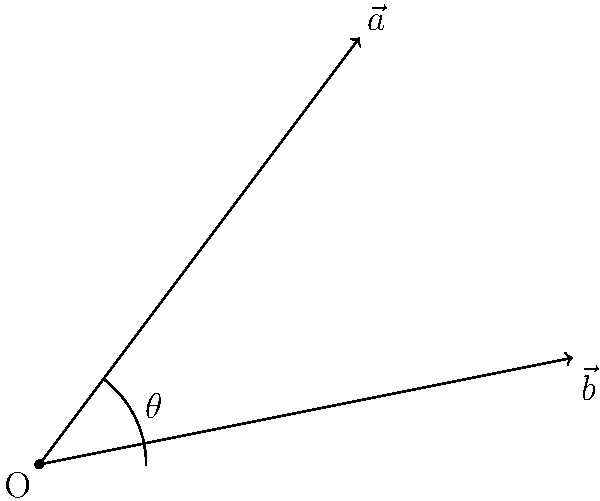In a hidden state park in the Sierra Nevada mountains, two hiking trails are represented by vectors $\vec{a} = (3, 4)$ and $\vec{b} = (5, 1)$. What is the angle $\theta$ between these two trails, rounded to the nearest degree? To find the angle between two vectors, we can use the dot product formula:

$$\cos \theta = \frac{\vec{a} \cdot \vec{b}}{|\vec{a}||\vec{b}|}$$

Step 1: Calculate the dot product $\vec{a} \cdot \vec{b}$
$$\vec{a} \cdot \vec{b} = (3)(5) + (4)(1) = 15 + 4 = 19$$

Step 2: Calculate the magnitudes of $\vec{a}$ and $\vec{b}$
$$|\vec{a}| = \sqrt{3^2 + 4^2} = \sqrt{9 + 16} = \sqrt{25} = 5$$
$$|\vec{b}| = \sqrt{5^2 + 1^2} = \sqrt{25 + 1} = \sqrt{26}$$

Step 3: Substitute into the formula
$$\cos \theta = \frac{19}{5\sqrt{26}}$$

Step 4: Take the inverse cosine (arccos) of both sides
$$\theta = \arccos(\frac{19}{5\sqrt{26}})$$

Step 5: Calculate and round to the nearest degree
$$\theta \approx 44.42^\circ \approx 44^\circ$$
Answer: 44° 